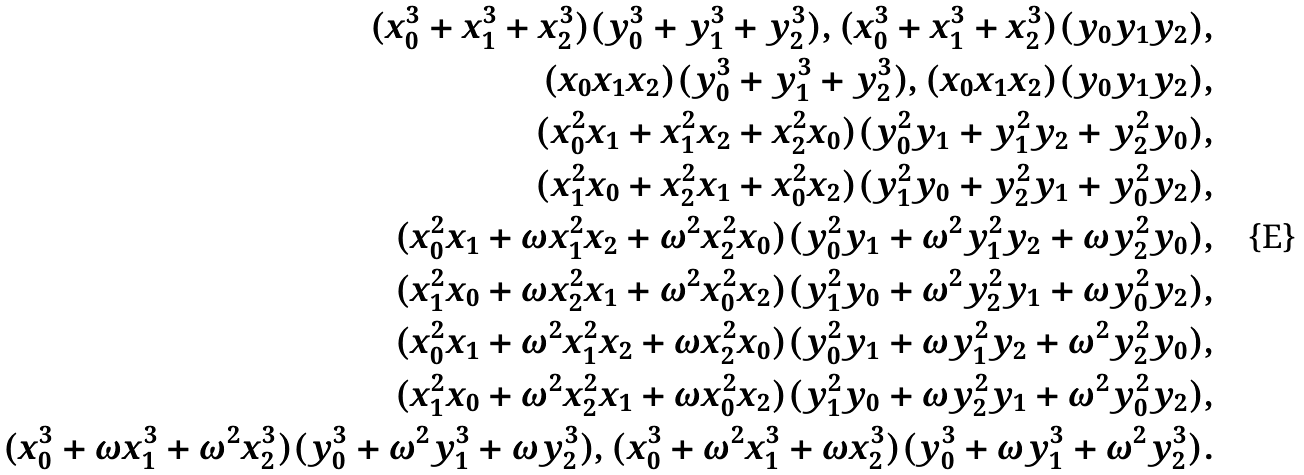Convert formula to latex. <formula><loc_0><loc_0><loc_500><loc_500>( x _ { 0 } ^ { 3 } + x _ { 1 } ^ { 3 } + x _ { 2 } ^ { 3 } ) ( y _ { 0 } ^ { 3 } + y _ { 1 } ^ { 3 } + y _ { 2 } ^ { 3 } ) , ( x _ { 0 } ^ { 3 } + x _ { 1 } ^ { 3 } + x _ { 2 } ^ { 3 } ) ( y _ { 0 } y _ { 1 } y _ { 2 } ) , \\ ( x _ { 0 } x _ { 1 } x _ { 2 } ) ( y _ { 0 } ^ { 3 } + y _ { 1 } ^ { 3 } + y _ { 2 } ^ { 3 } ) , ( x _ { 0 } x _ { 1 } x _ { 2 } ) ( y _ { 0 } y _ { 1 } y _ { 2 } ) , \\ ( x _ { 0 } ^ { 2 } x _ { 1 } + x _ { 1 } ^ { 2 } x _ { 2 } + x _ { 2 } ^ { 2 } x _ { 0 } ) ( y _ { 0 } ^ { 2 } y _ { 1 } + y _ { 1 } ^ { 2 } y _ { 2 } + y _ { 2 } ^ { 2 } y _ { 0 } ) , \\ ( x _ { 1 } ^ { 2 } x _ { 0 } + x _ { 2 } ^ { 2 } x _ { 1 } + x _ { 0 } ^ { 2 } x _ { 2 } ) ( y _ { 1 } ^ { 2 } y _ { 0 } + y _ { 2 } ^ { 2 } y _ { 1 } + y _ { 0 } ^ { 2 } y _ { 2 } ) , \\ ( x _ { 0 } ^ { 2 } x _ { 1 } + \omega x _ { 1 } ^ { 2 } x _ { 2 } + \omega ^ { 2 } x _ { 2 } ^ { 2 } x _ { 0 } ) ( y _ { 0 } ^ { 2 } y _ { 1 } + \omega ^ { 2 } y _ { 1 } ^ { 2 } y _ { 2 } + \omega y _ { 2 } ^ { 2 } y _ { 0 } ) , \\ ( x _ { 1 } ^ { 2 } x _ { 0 } + \omega x _ { 2 } ^ { 2 } x _ { 1 } + \omega ^ { 2 } x _ { 0 } ^ { 2 } x _ { 2 } ) ( y _ { 1 } ^ { 2 } y _ { 0 } + \omega ^ { 2 } y _ { 2 } ^ { 2 } y _ { 1 } + \omega y _ { 0 } ^ { 2 } y _ { 2 } ) , \\ ( x _ { 0 } ^ { 2 } x _ { 1 } + \omega ^ { 2 } x _ { 1 } ^ { 2 } x _ { 2 } + \omega x _ { 2 } ^ { 2 } x _ { 0 } ) ( y _ { 0 } ^ { 2 } y _ { 1 } + \omega y _ { 1 } ^ { 2 } y _ { 2 } + \omega ^ { 2 } y _ { 2 } ^ { 2 } y _ { 0 } ) , \\ ( x _ { 1 } ^ { 2 } x _ { 0 } + \omega ^ { 2 } x _ { 2 } ^ { 2 } x _ { 1 } + \omega x _ { 0 } ^ { 2 } x _ { 2 } ) ( y _ { 1 } ^ { 2 } y _ { 0 } + \omega y _ { 2 } ^ { 2 } y _ { 1 } + \omega ^ { 2 } y _ { 0 } ^ { 2 } y _ { 2 } ) , \\ ( x _ { 0 } ^ { 3 } + \omega x _ { 1 } ^ { 3 } + \omega ^ { 2 } x _ { 2 } ^ { 3 } ) ( y _ { 0 } ^ { 3 } + \omega ^ { 2 } y _ { 1 } ^ { 3 } + \omega y _ { 2 } ^ { 3 } ) , ( x _ { 0 } ^ { 3 } + \omega ^ { 2 } x _ { 1 } ^ { 3 } + \omega x _ { 2 } ^ { 3 } ) ( y _ { 0 } ^ { 3 } + \omega y _ { 1 } ^ { 3 } + \omega ^ { 2 } y _ { 2 } ^ { 3 } ) .</formula> 